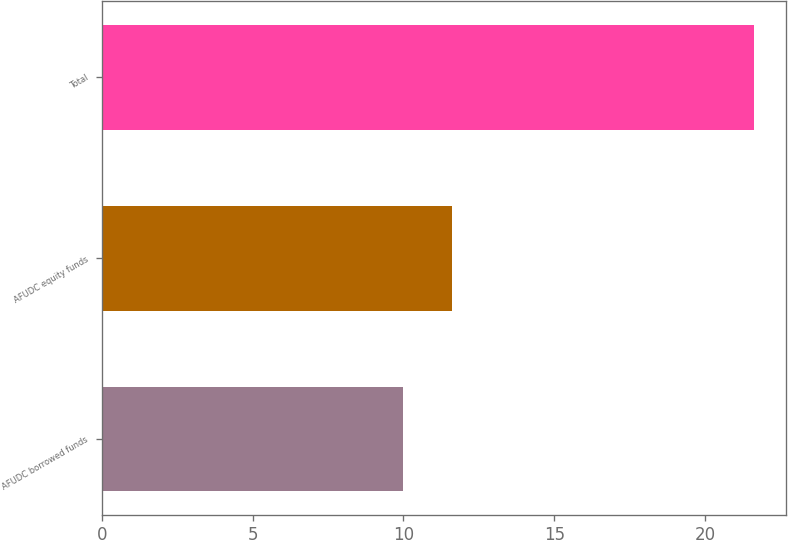<chart> <loc_0><loc_0><loc_500><loc_500><bar_chart><fcel>AFUDC borrowed funds<fcel>AFUDC equity funds<fcel>Total<nl><fcel>10<fcel>11.6<fcel>21.6<nl></chart> 